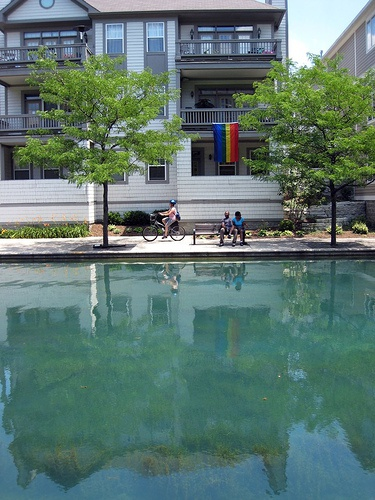Describe the objects in this image and their specific colors. I can see bicycle in lavender, gray, black, white, and darkgray tones, bench in lavender, gray, black, darkgray, and lightgray tones, people in lavender, gray, darkgray, and lightgray tones, people in lavender, black, teal, gray, and navy tones, and people in lavender, black, gray, and navy tones in this image. 